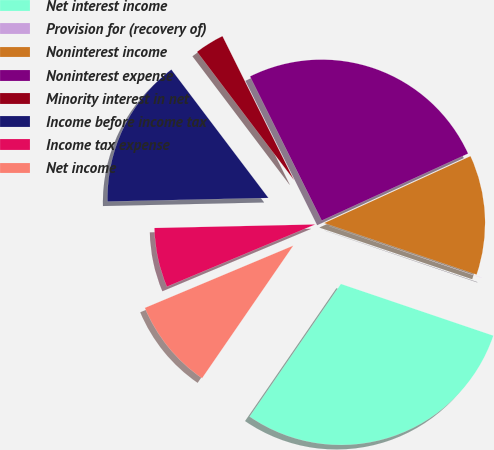<chart> <loc_0><loc_0><loc_500><loc_500><pie_chart><fcel>Net interest income<fcel>Provision for (recovery of)<fcel>Noninterest income<fcel>Noninterest expense<fcel>Minority interest in net<fcel>Income before income tax<fcel>Income tax expense<fcel>Net income<nl><fcel>29.38%<fcel>0.02%<fcel>12.02%<fcel>25.51%<fcel>2.96%<fcel>15.05%<fcel>5.97%<fcel>9.09%<nl></chart> 